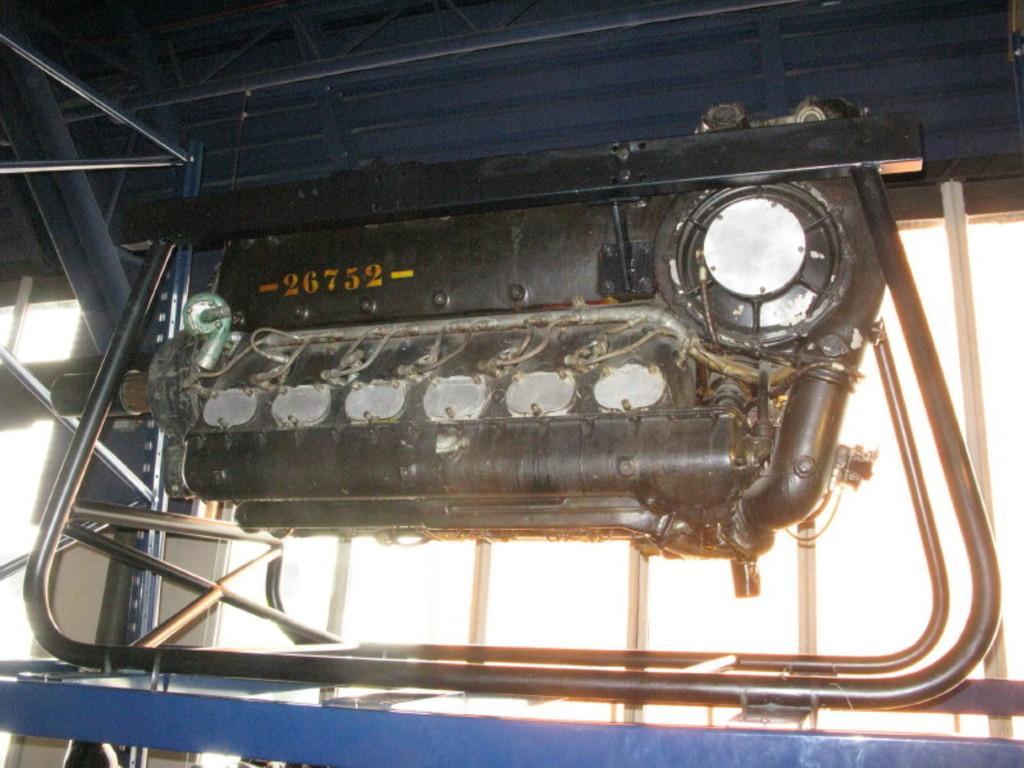Describe this image in one or two sentences. In this picture, we see the engine or the motor of the machine. It is black in color. In the background, we see a white wall. At the top, it is blue in color and we see some iron rods. 